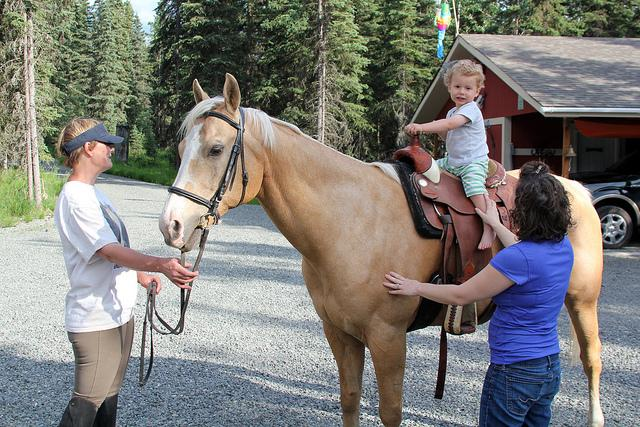Which one is probably the most proficient rider? left woman 